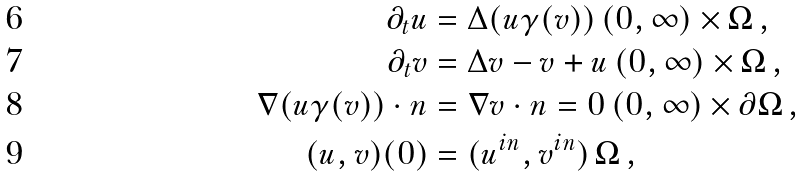Convert formula to latex. <formula><loc_0><loc_0><loc_500><loc_500>\partial _ { t } u & = \Delta ( u \gamma ( v ) ) \, ( 0 , \infty ) \times \Omega \, , \\ \partial _ { t } v & = \Delta v - v + u \, ( 0 , \infty ) \times \Omega \, , \\ \nabla ( u \gamma ( v ) ) \cdot n & = \nabla v \cdot n = 0 \, ( 0 , \infty ) \times \partial \Omega \, , \\ ( u , v ) ( 0 ) & = ( u ^ { i n } , v ^ { i n } ) \, \Omega \, ,</formula> 